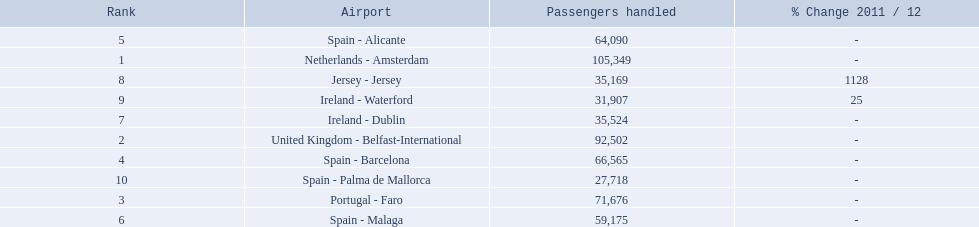What is the best rank? 1. What is the airport? Netherlands - Amsterdam. 